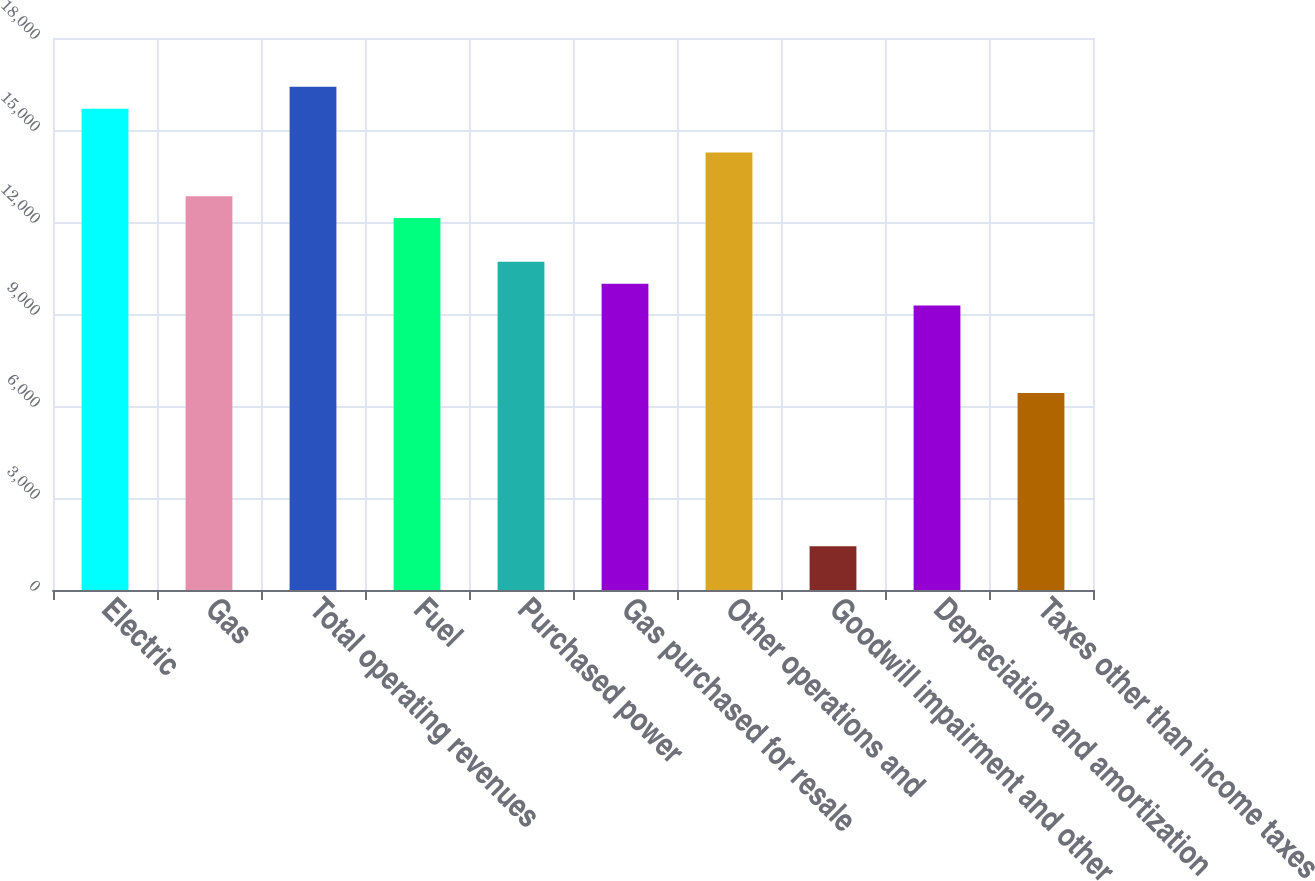Convert chart. <chart><loc_0><loc_0><loc_500><loc_500><bar_chart><fcel>Electric<fcel>Gas<fcel>Total operating revenues<fcel>Fuel<fcel>Purchased power<fcel>Gas purchased for resale<fcel>Other operations and<fcel>Goodwill impairment and other<fcel>Depreciation and amortization<fcel>Taxes other than income taxes<nl><fcel>15695.2<fcel>12841.8<fcel>16408.6<fcel>12128.5<fcel>10701.8<fcel>9988.44<fcel>14268.5<fcel>1428.24<fcel>9275.09<fcel>6421.69<nl></chart> 